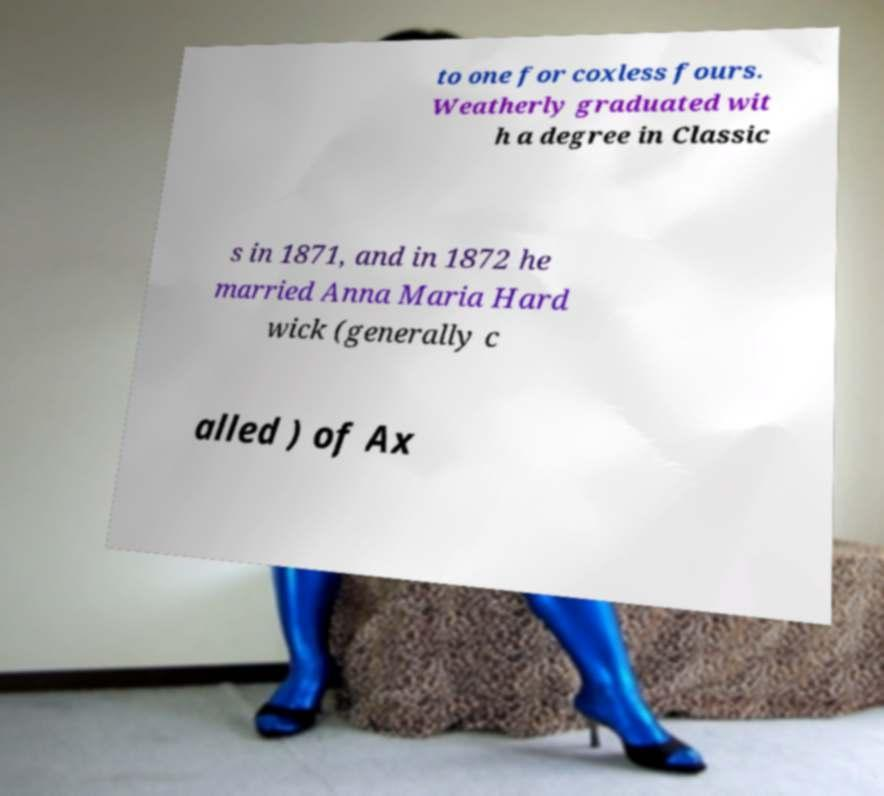There's text embedded in this image that I need extracted. Can you transcribe it verbatim? to one for coxless fours. Weatherly graduated wit h a degree in Classic s in 1871, and in 1872 he married Anna Maria Hard wick (generally c alled ) of Ax 